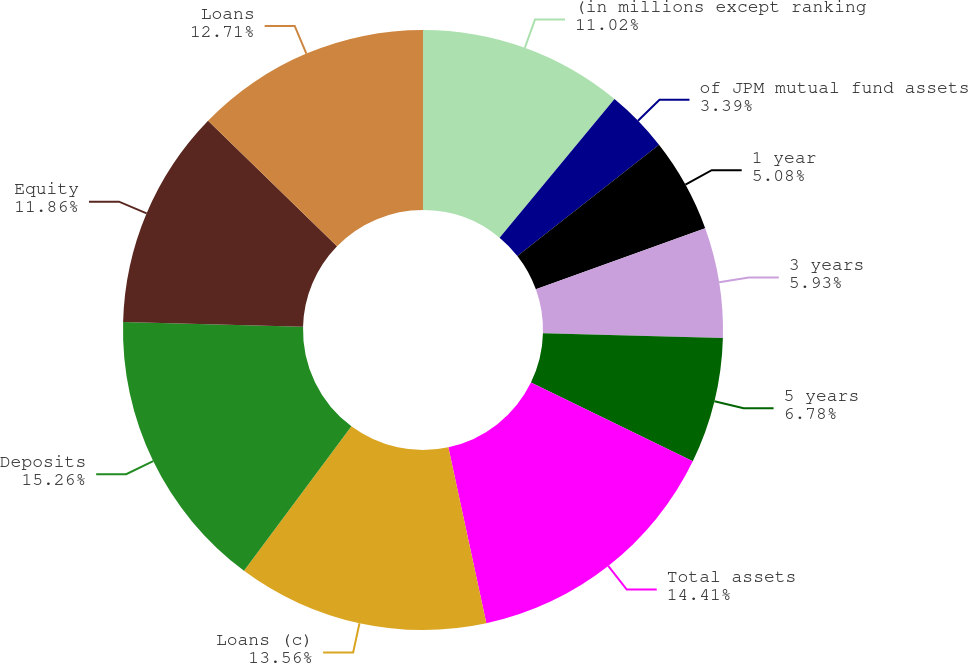<chart> <loc_0><loc_0><loc_500><loc_500><pie_chart><fcel>(in millions except ranking<fcel>of JPM mutual fund assets<fcel>1 year<fcel>3 years<fcel>5 years<fcel>Total assets<fcel>Loans (c)<fcel>Deposits<fcel>Equity<fcel>Loans<nl><fcel>11.02%<fcel>3.39%<fcel>5.08%<fcel>5.93%<fcel>6.78%<fcel>14.41%<fcel>13.56%<fcel>15.25%<fcel>11.86%<fcel>12.71%<nl></chart> 